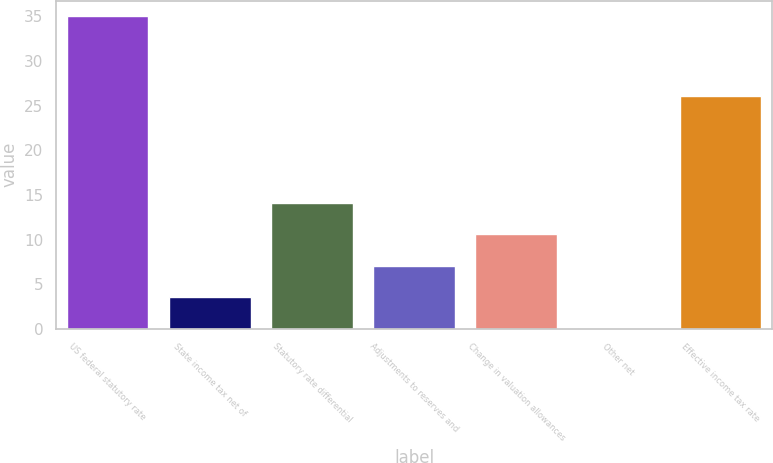Convert chart. <chart><loc_0><loc_0><loc_500><loc_500><bar_chart><fcel>US federal statutory rate<fcel>State income tax net of<fcel>Statutory rate differential<fcel>Adjustments to reserves and<fcel>Change in valuation allowances<fcel>Other net<fcel>Effective income tax rate<nl><fcel>35<fcel>3.59<fcel>14.06<fcel>7.08<fcel>10.57<fcel>0.1<fcel>26.1<nl></chart> 